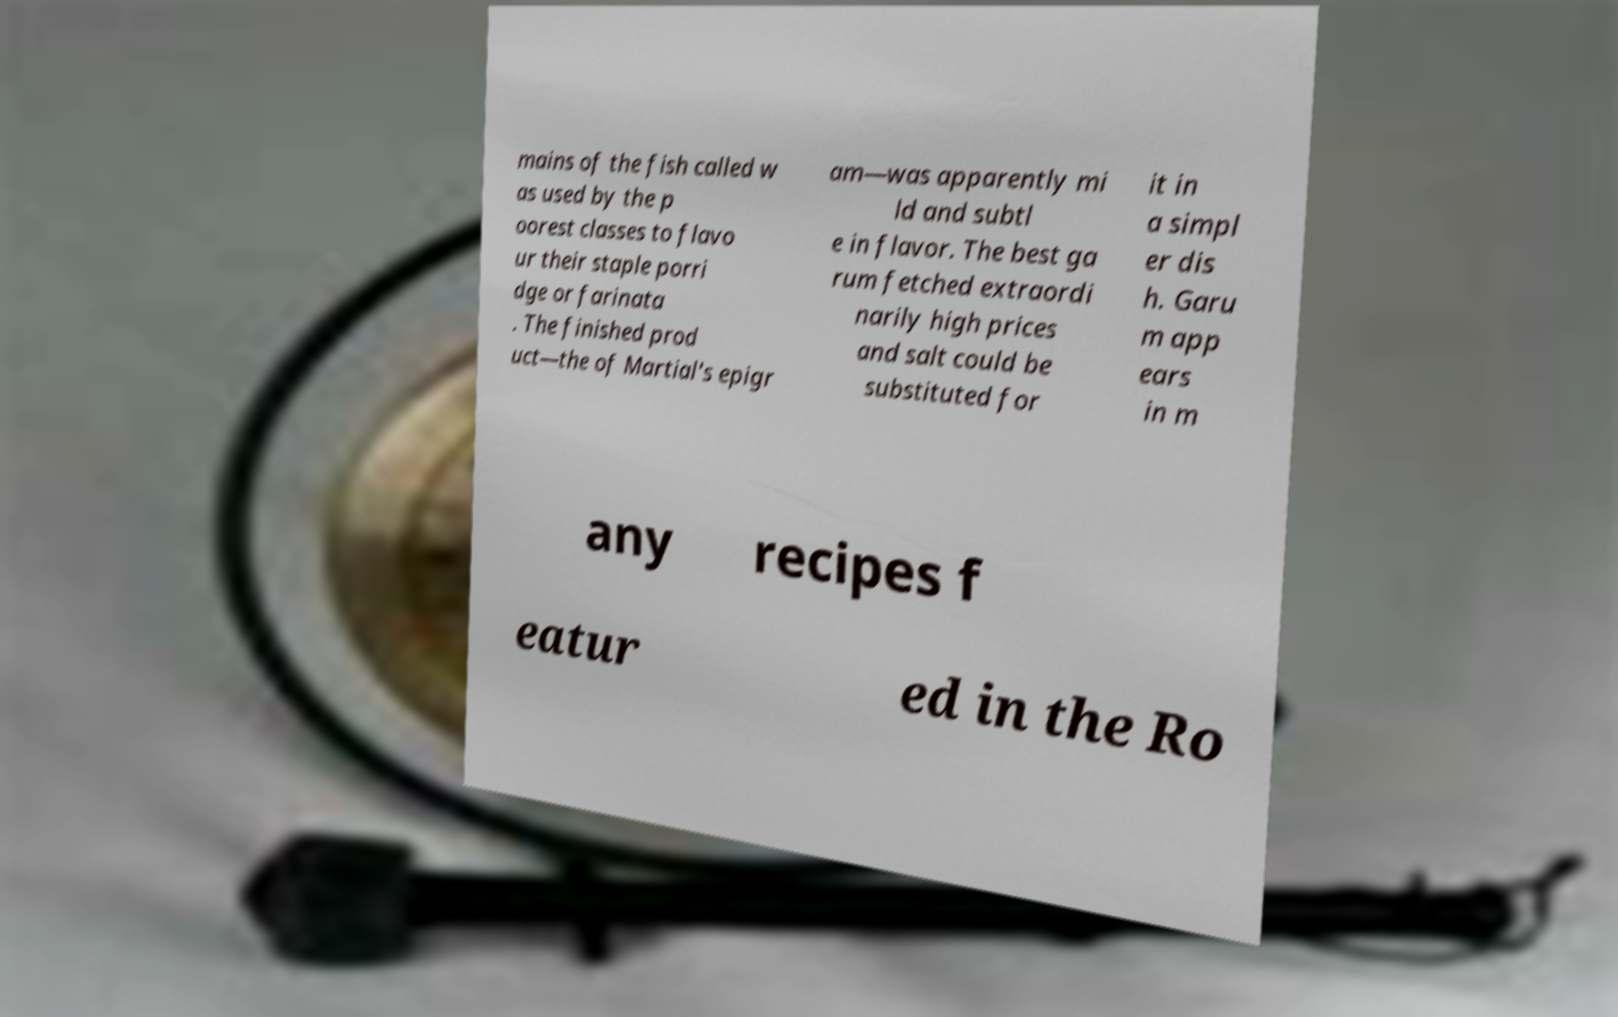I need the written content from this picture converted into text. Can you do that? mains of the fish called w as used by the p oorest classes to flavo ur their staple porri dge or farinata . The finished prod uct—the of Martial's epigr am—was apparently mi ld and subtl e in flavor. The best ga rum fetched extraordi narily high prices and salt could be substituted for it in a simpl er dis h. Garu m app ears in m any recipes f eatur ed in the Ro 